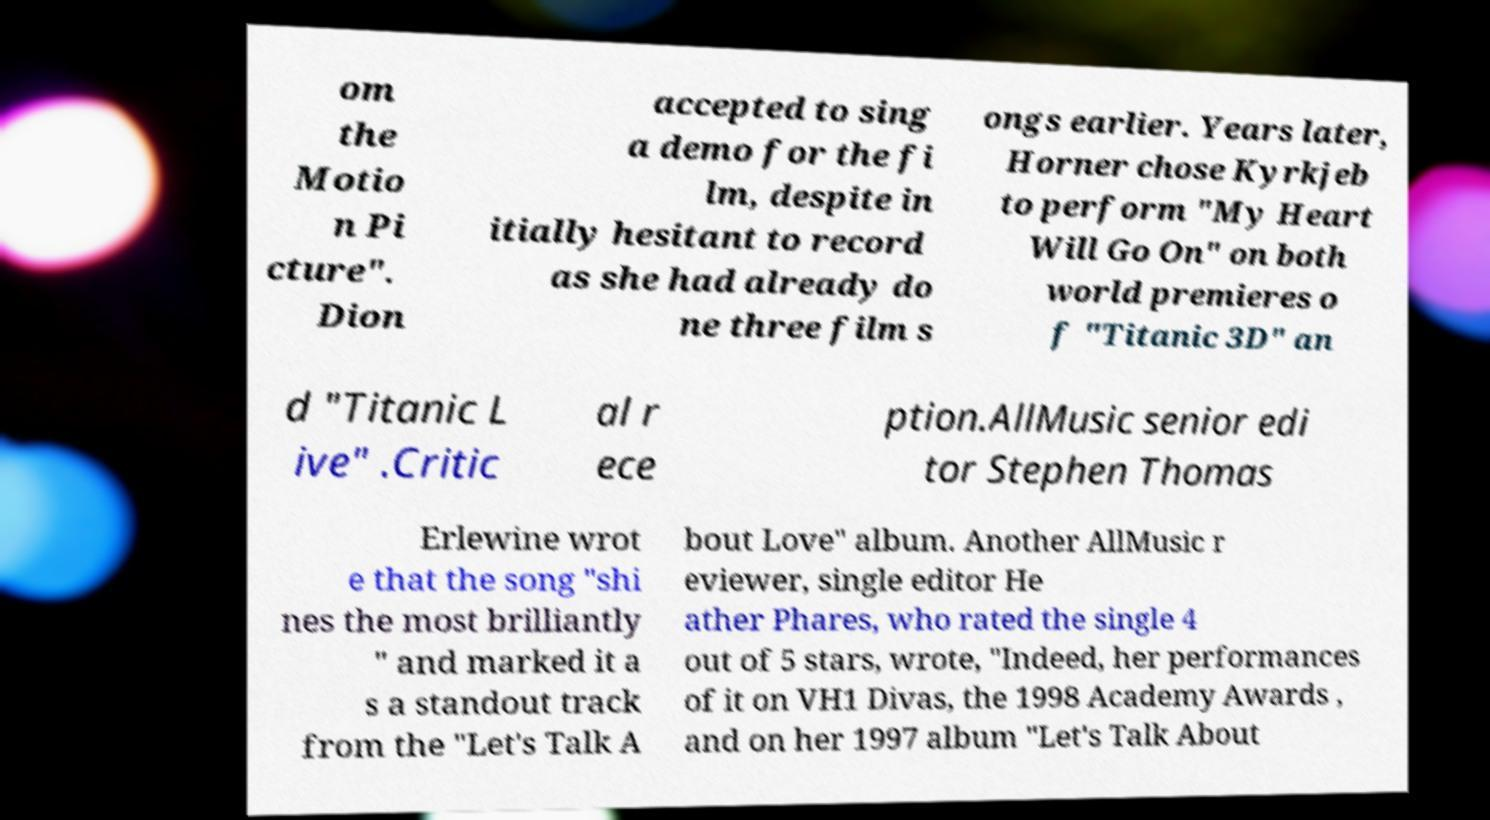Could you extract and type out the text from this image? om the Motio n Pi cture". Dion accepted to sing a demo for the fi lm, despite in itially hesitant to record as she had already do ne three film s ongs earlier. Years later, Horner chose Kyrkjeb to perform "My Heart Will Go On" on both world premieres o f "Titanic 3D" an d "Titanic L ive" .Critic al r ece ption.AllMusic senior edi tor Stephen Thomas Erlewine wrot e that the song "shi nes the most brilliantly " and marked it a s a standout track from the "Let's Talk A bout Love" album. Another AllMusic r eviewer, single editor He ather Phares, who rated the single 4 out of 5 stars, wrote, "Indeed, her performances of it on VH1 Divas, the 1998 Academy Awards , and on her 1997 album "Let's Talk About 